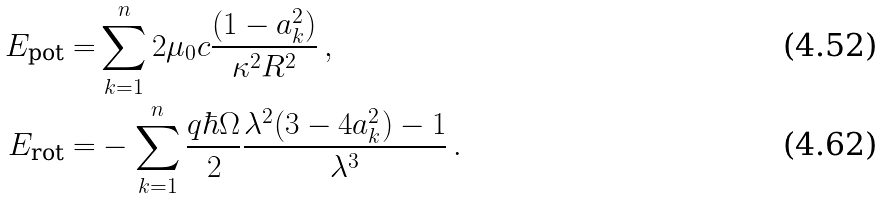<formula> <loc_0><loc_0><loc_500><loc_500>E _ { \text {pot} } = & \sum _ { k = 1 } ^ { n } 2 \mu _ { 0 } c \frac { ( 1 - a _ { k } ^ { 2 } ) } { \kappa ^ { 2 } R ^ { 2 } } \, , \\ E _ { \text {rot} } = & - \sum _ { k = 1 } ^ { n } \frac { q \hbar { \Omega } } { 2 } \frac { \lambda ^ { 2 } ( 3 - 4 a _ { k } ^ { 2 } ) - 1 } { \lambda ^ { 3 } } \, .</formula> 